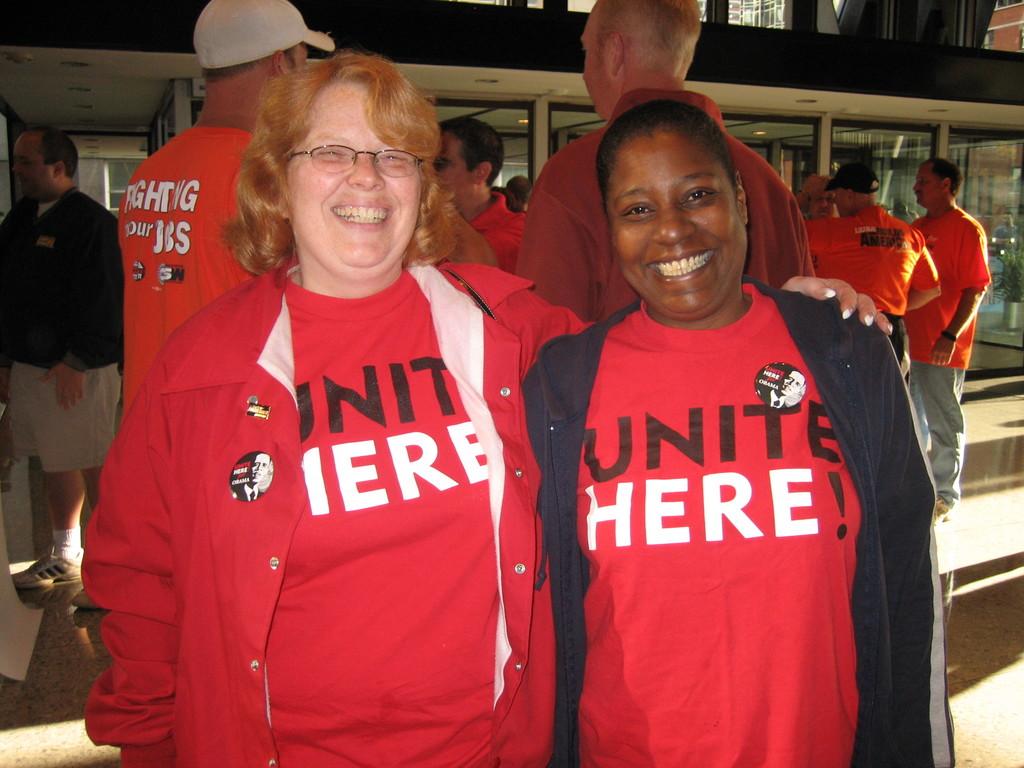What are people planning to do at this location?
Ensure brevity in your answer.  Unite. What do the two women's t-shirts say?
Give a very brief answer. Unite here!. 